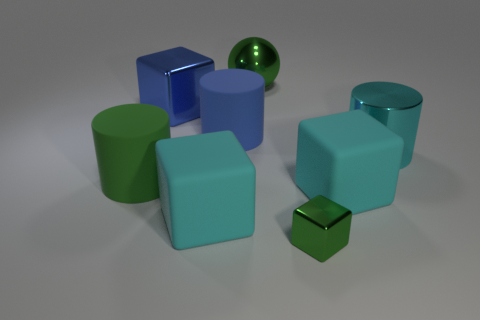What number of things are either large yellow matte spheres or small green cubes?
Offer a very short reply. 1. What is the color of the small metallic block that is in front of the large blue object that is behind the matte cylinder behind the metal cylinder?
Offer a very short reply. Green. Are there any other things that are the same color as the tiny shiny thing?
Your answer should be very brief. Yes. Is the size of the green shiny cube the same as the blue block?
Keep it short and to the point. No. How many things are either cylinders that are on the left side of the small green thing or matte objects that are in front of the large cyan cylinder?
Provide a short and direct response. 4. What material is the large green thing in front of the metallic thing behind the blue metallic thing?
Your answer should be compact. Rubber. What number of other objects are the same material as the small thing?
Provide a succinct answer. 3. Do the cyan metal thing and the large green shiny thing have the same shape?
Your answer should be very brief. No. There is a cylinder that is left of the blue matte object; how big is it?
Ensure brevity in your answer.  Large. There is a green cylinder; is its size the same as the green metal thing that is behind the tiny metallic cube?
Make the answer very short. Yes. 